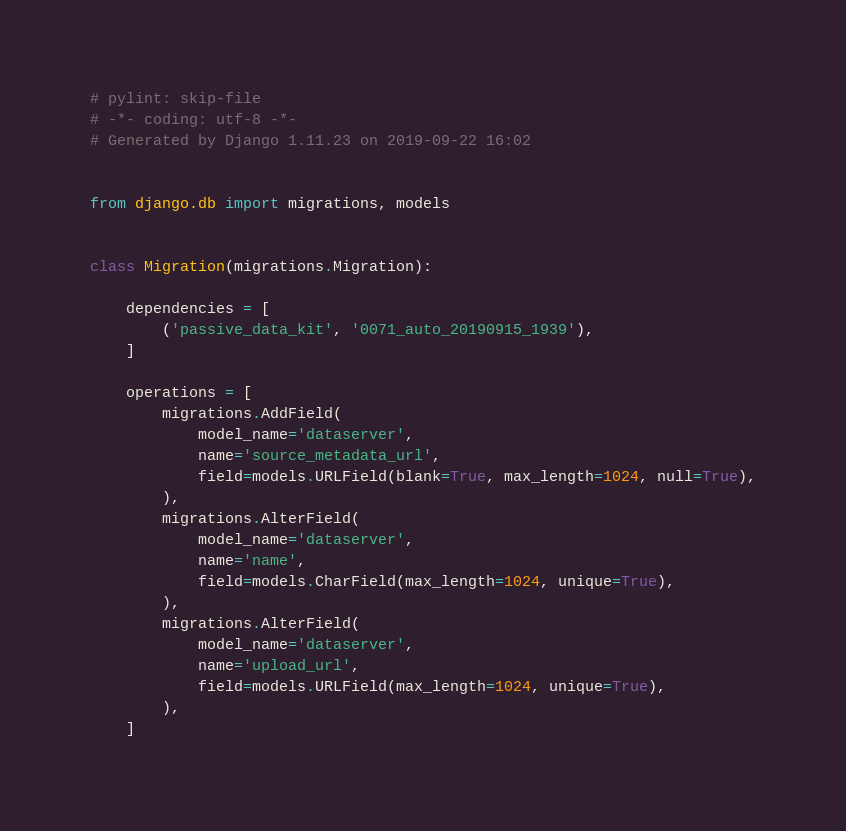Convert code to text. <code><loc_0><loc_0><loc_500><loc_500><_Python_># pylint: skip-file
# -*- coding: utf-8 -*-
# Generated by Django 1.11.23 on 2019-09-22 16:02


from django.db import migrations, models


class Migration(migrations.Migration):

    dependencies = [
        ('passive_data_kit', '0071_auto_20190915_1939'),
    ]

    operations = [
        migrations.AddField(
            model_name='dataserver',
            name='source_metadata_url',
            field=models.URLField(blank=True, max_length=1024, null=True),
        ),
        migrations.AlterField(
            model_name='dataserver',
            name='name',
            field=models.CharField(max_length=1024, unique=True),
        ),
        migrations.AlterField(
            model_name='dataserver',
            name='upload_url',
            field=models.URLField(max_length=1024, unique=True),
        ),
    ]
</code> 